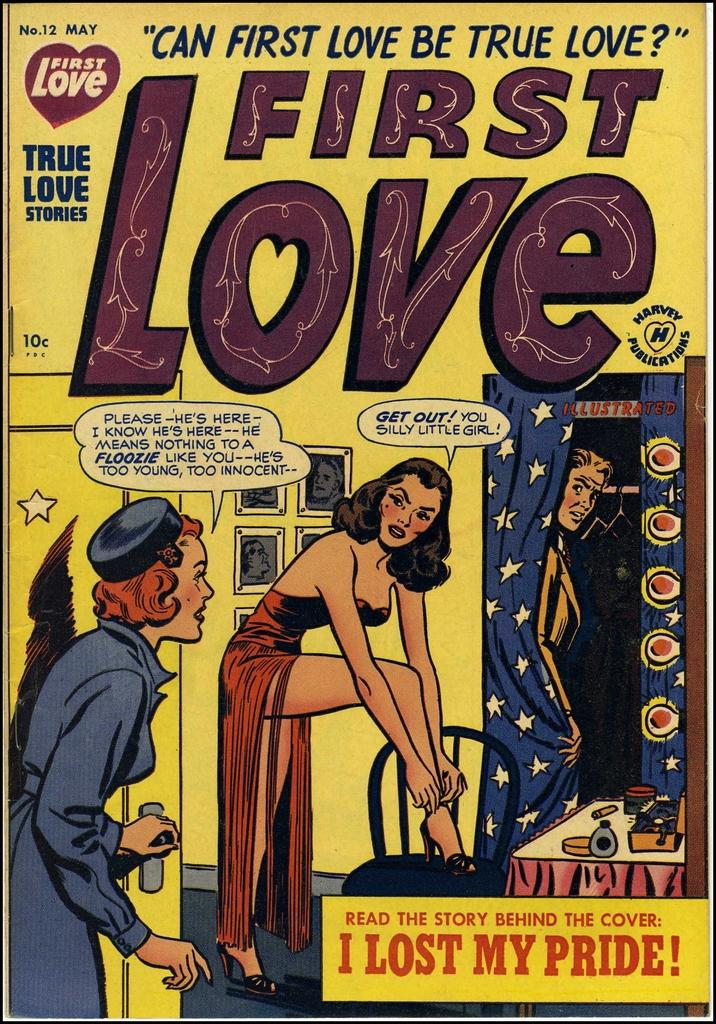Provide a one-sentence caption for the provided image. A First Love comic book contains a story called I Lost My Pride!. 